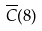<formula> <loc_0><loc_0><loc_500><loc_500>\overline { C } ( 8 )</formula> 